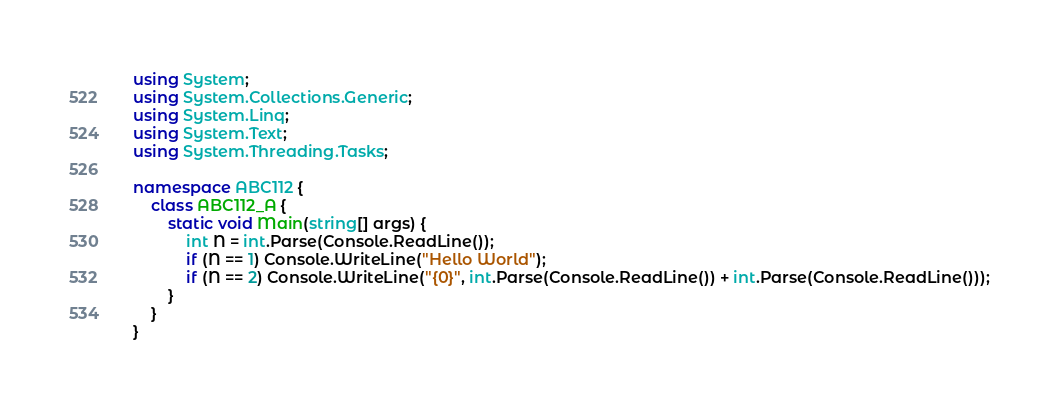Convert code to text. <code><loc_0><loc_0><loc_500><loc_500><_C#_>using System;
using System.Collections.Generic;
using System.Linq;
using System.Text;
using System.Threading.Tasks;

namespace ABC112 {
	class ABC112_A {
		static void Main(string[] args) {
			int N = int.Parse(Console.ReadLine());
			if (N == 1) Console.WriteLine("Hello World");
			if (N == 2) Console.WriteLine("{0}", int.Parse(Console.ReadLine()) + int.Parse(Console.ReadLine()));
		}
	}
}
</code> 